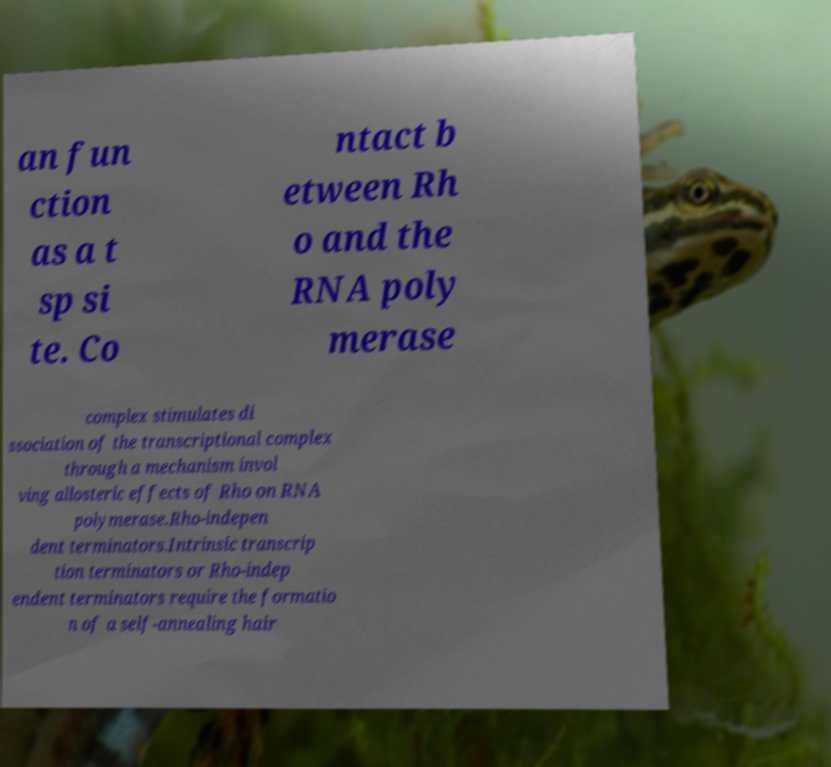Could you extract and type out the text from this image? an fun ction as a t sp si te. Co ntact b etween Rh o and the RNA poly merase complex stimulates di ssociation of the transcriptional complex through a mechanism invol ving allosteric effects of Rho on RNA polymerase.Rho-indepen dent terminators.Intrinsic transcrip tion terminators or Rho-indep endent terminators require the formatio n of a self-annealing hair 